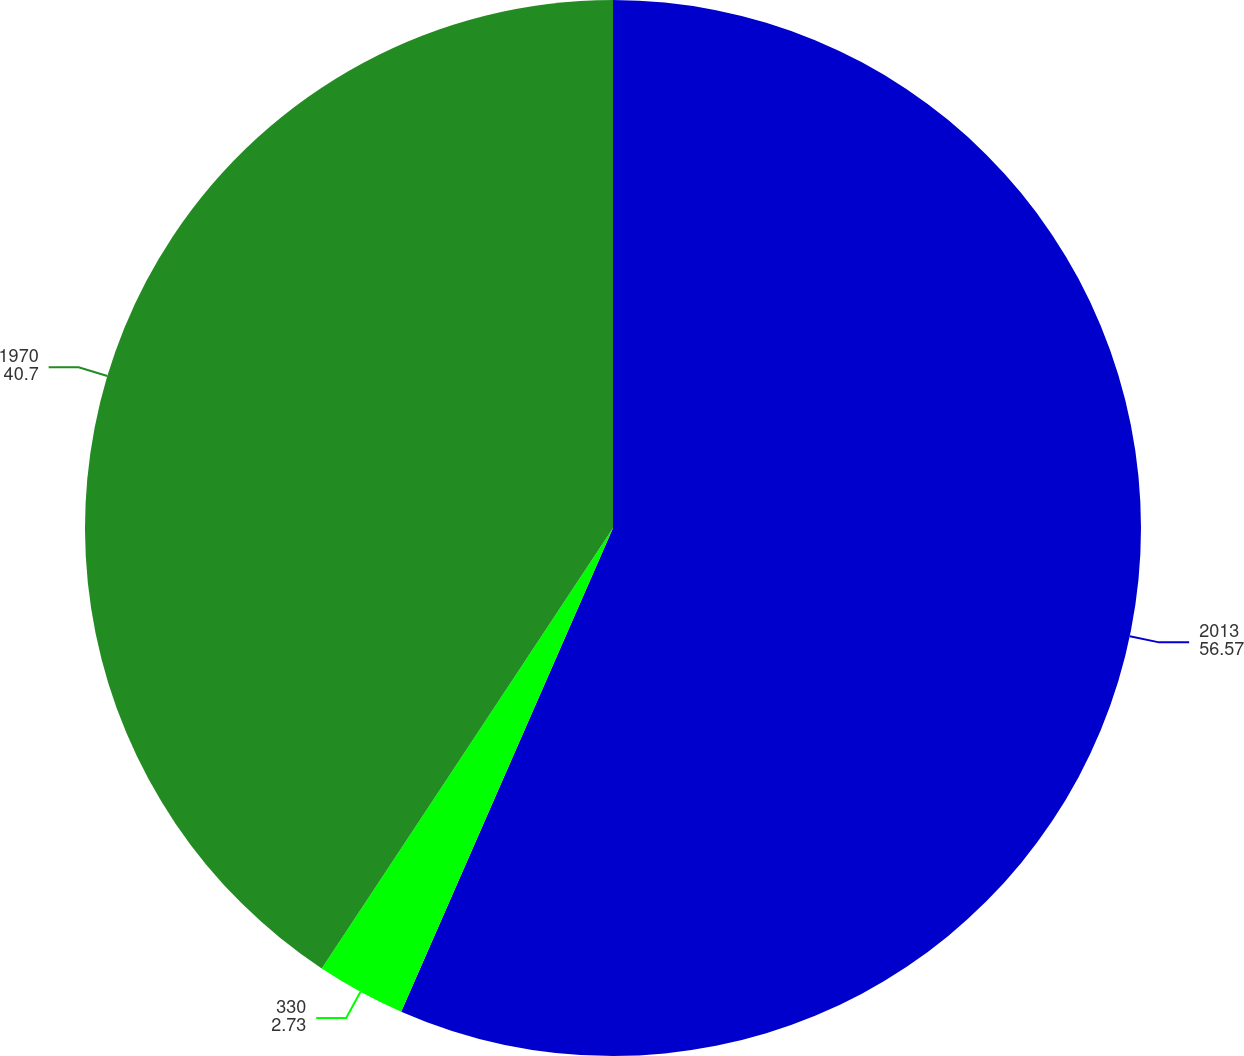<chart> <loc_0><loc_0><loc_500><loc_500><pie_chart><fcel>2013<fcel>330<fcel>1970<nl><fcel>56.57%<fcel>2.73%<fcel>40.7%<nl></chart> 